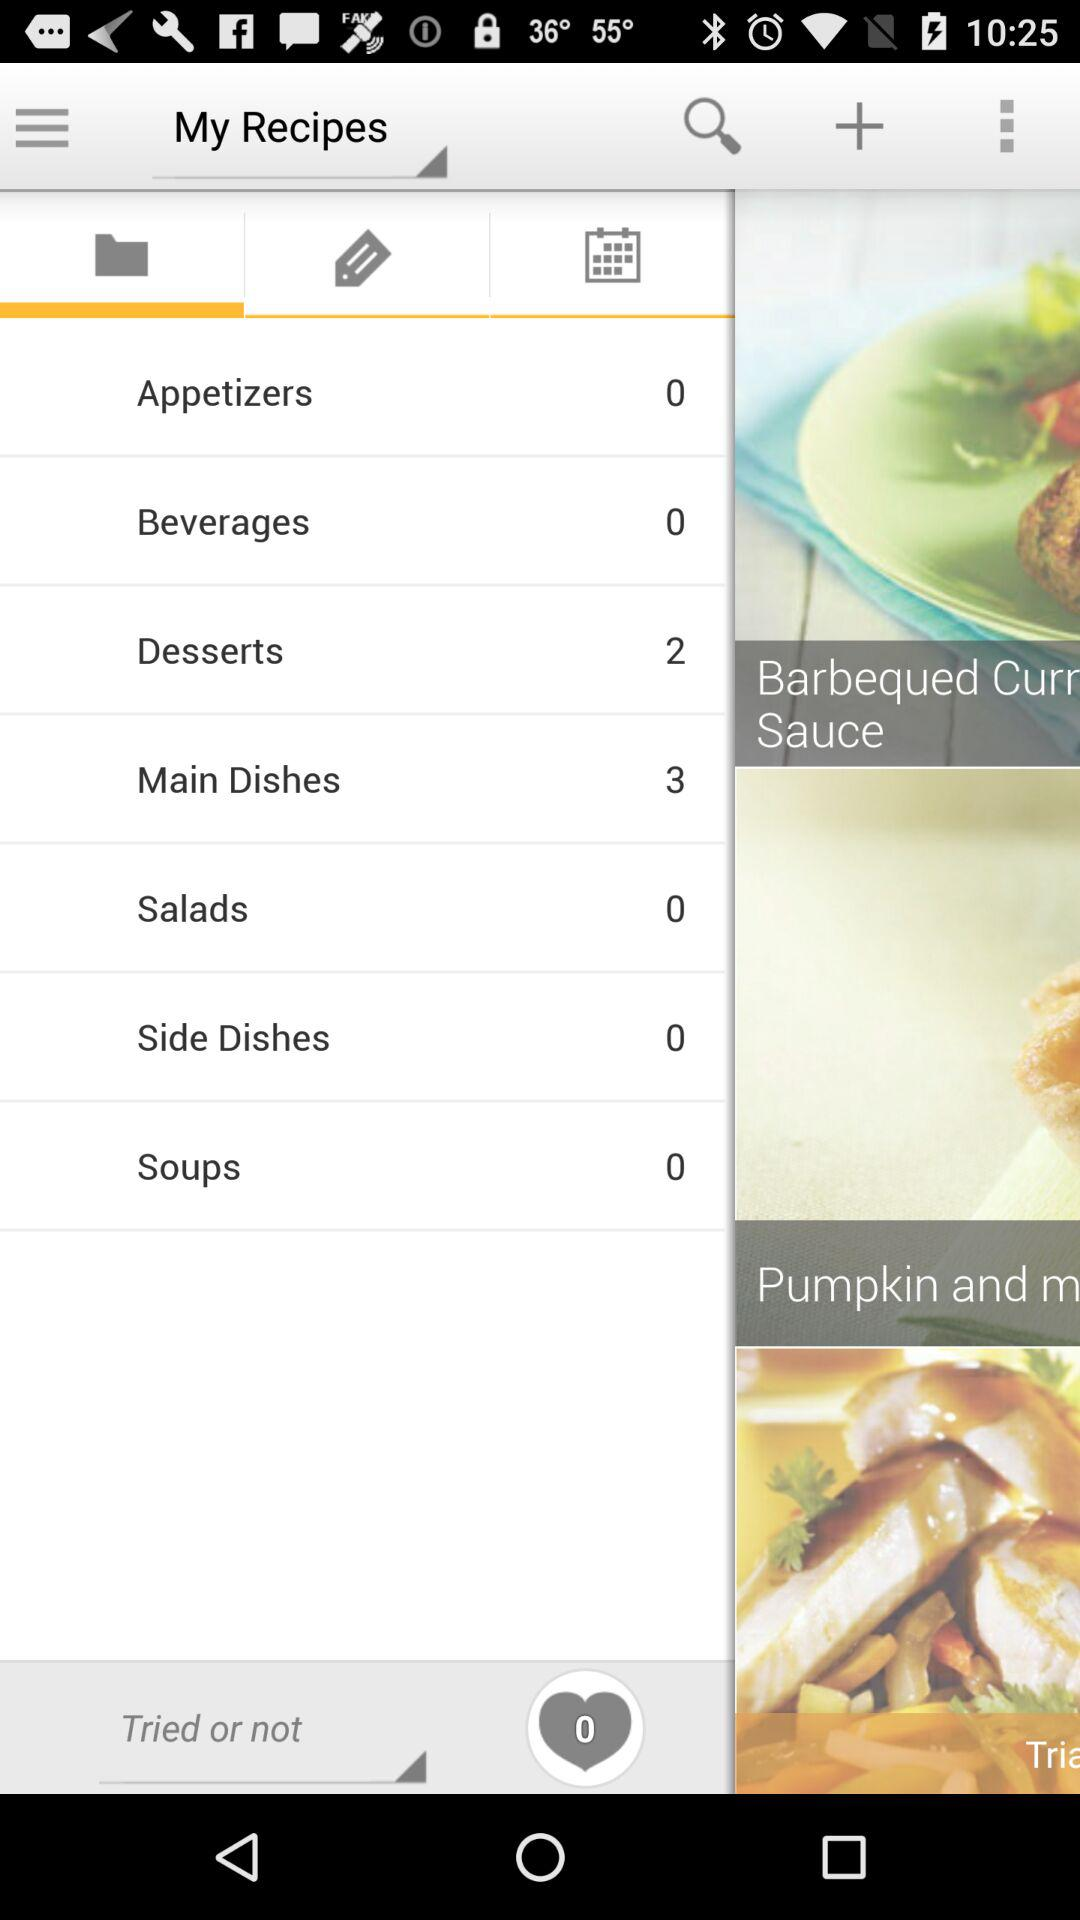How many recipes of desserts are there? There are 2 recipes. 